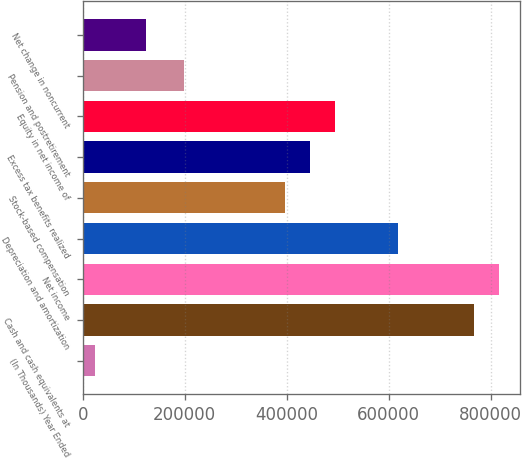Convert chart to OTSL. <chart><loc_0><loc_0><loc_500><loc_500><bar_chart><fcel>(In Thousands) Year Ended<fcel>Cash and cash equivalents at<fcel>Net income<fcel>Depreciation and amortization<fcel>Stock-based compensation<fcel>Excess tax benefits realized<fcel>Equity in net income of<fcel>Pension and postretirement<fcel>Net change in noncurrent<nl><fcel>24844.7<fcel>766436<fcel>815875<fcel>618118<fcel>395640<fcel>445080<fcel>494519<fcel>197883<fcel>123724<nl></chart> 